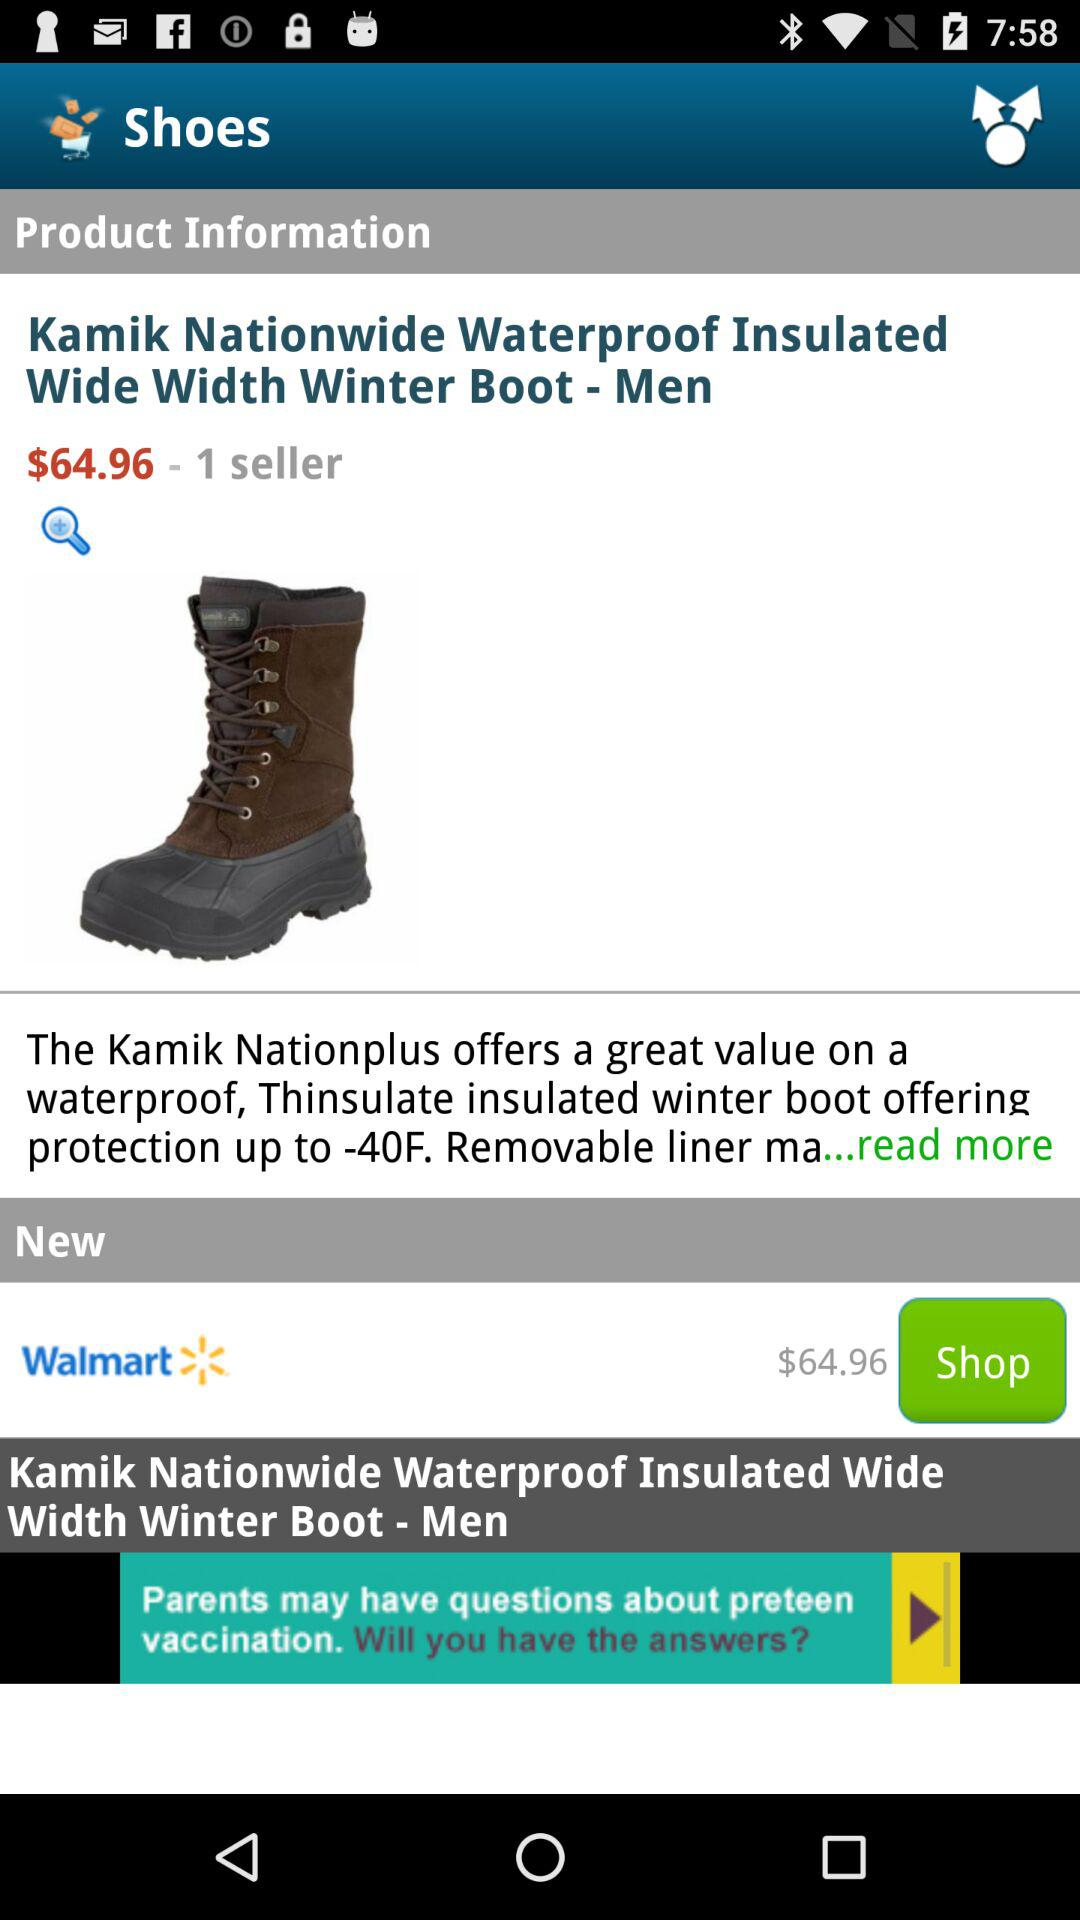How many sellers are there for the Kamik Nationwide Waterproof Insulated Wide Width Winter Boot - Men?
Answer the question using a single word or phrase. 1 